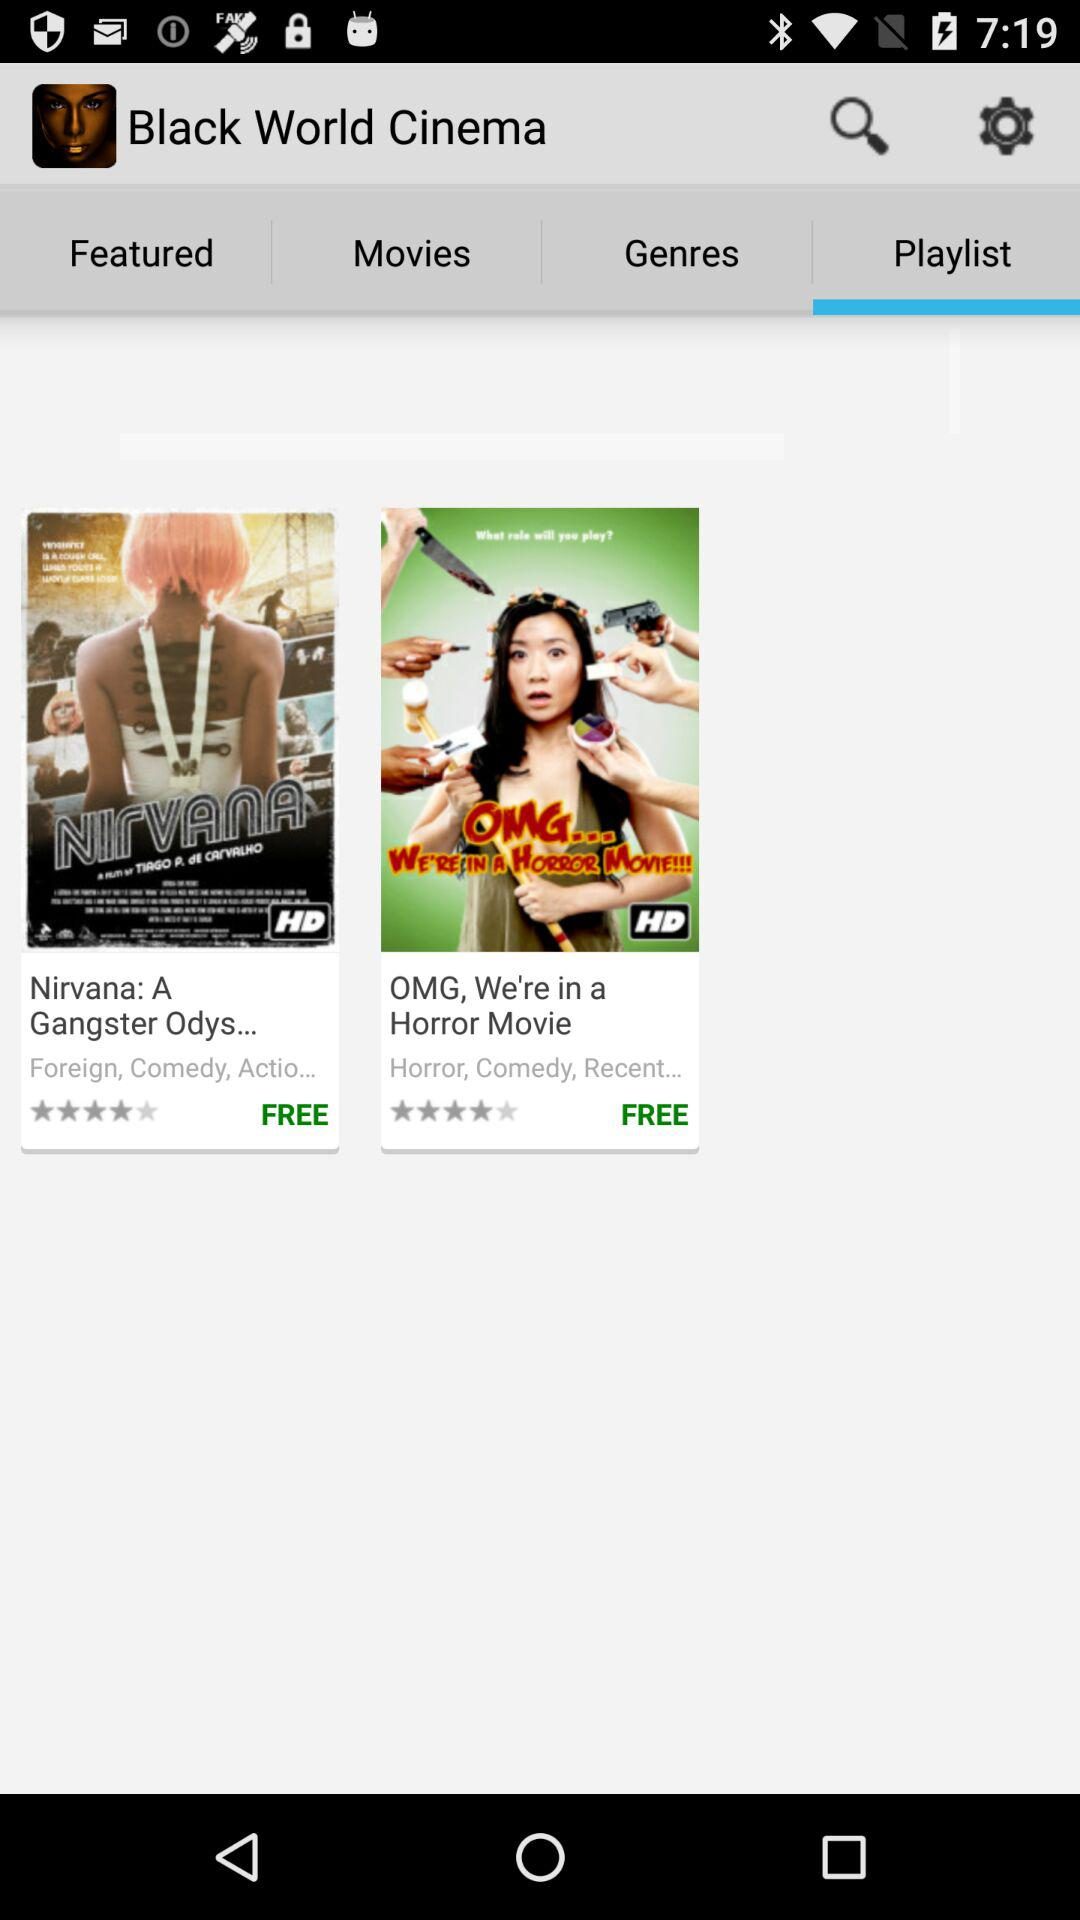Is the "Nirvana" movie free or paid?
Answer the question using a single word or phrase. It is free. 